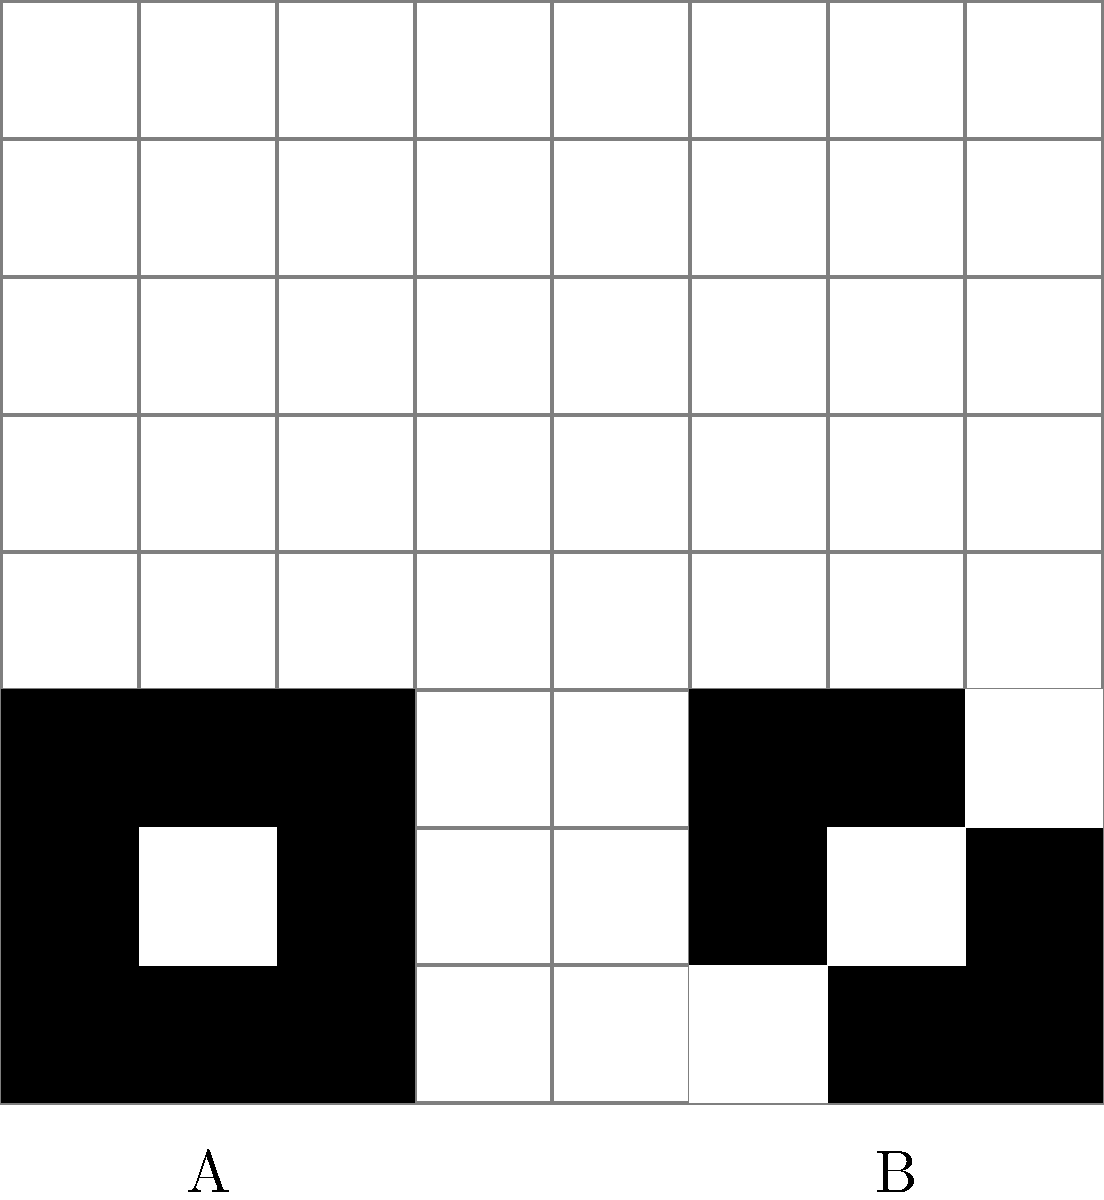When designing a custom boot logo for a retro console with limited color depth and resolution, which of the above pixel art designs (A or B) would be more suitable, and why? To determine the most suitable design for a retro console boot logo, we need to consider several factors:

1. Color depth: Retro consoles often have limited color palettes. Both designs use only two colors (black and white), which is suitable for systems with low color depth.

2. Resolution: Retro consoles typically have low-resolution displays. Both designs are simple and recognizable at small sizes.

3. Memory constraints: Simpler designs require less memory to store and display.

4. Symmetry: Symmetrical designs are often more visually appealing and easier to recognize.

5. Negative space usage: Effective use of negative space can make a design more memorable.

Analyzing the designs:

Design A:
- Simple 3x3 pixel square with a 2x2 pixel white square inside.
- Perfectly symmetrical.
- Uses less memory due to its simplicity.
- Limited use of negative space.

Design B:
- 4x4 pixel design with a more complex pattern.
- Asymmetrical, creating a more dynamic look.
- Uses more memory than Design A, but still relatively simple.
- Better use of negative space, creating an interesting diagonal pattern.

Considering these factors, Design B would be more suitable for a retro console boot logo. While it's slightly more complex than Design A, it offers a more visually interesting and memorable design without significantly increasing memory usage or complexity. The asymmetry and better use of negative space in Design B create a more distinctive logo that's still easily recognizable at low resolutions.
Answer: Design B 